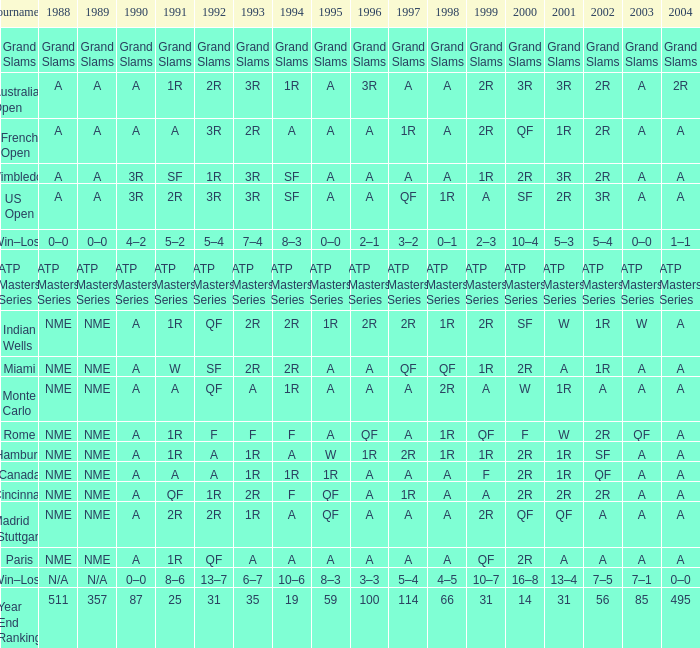What shows for 202 when the 1994 is A, the 1989 is NME, and the 199 is 2R? A. 